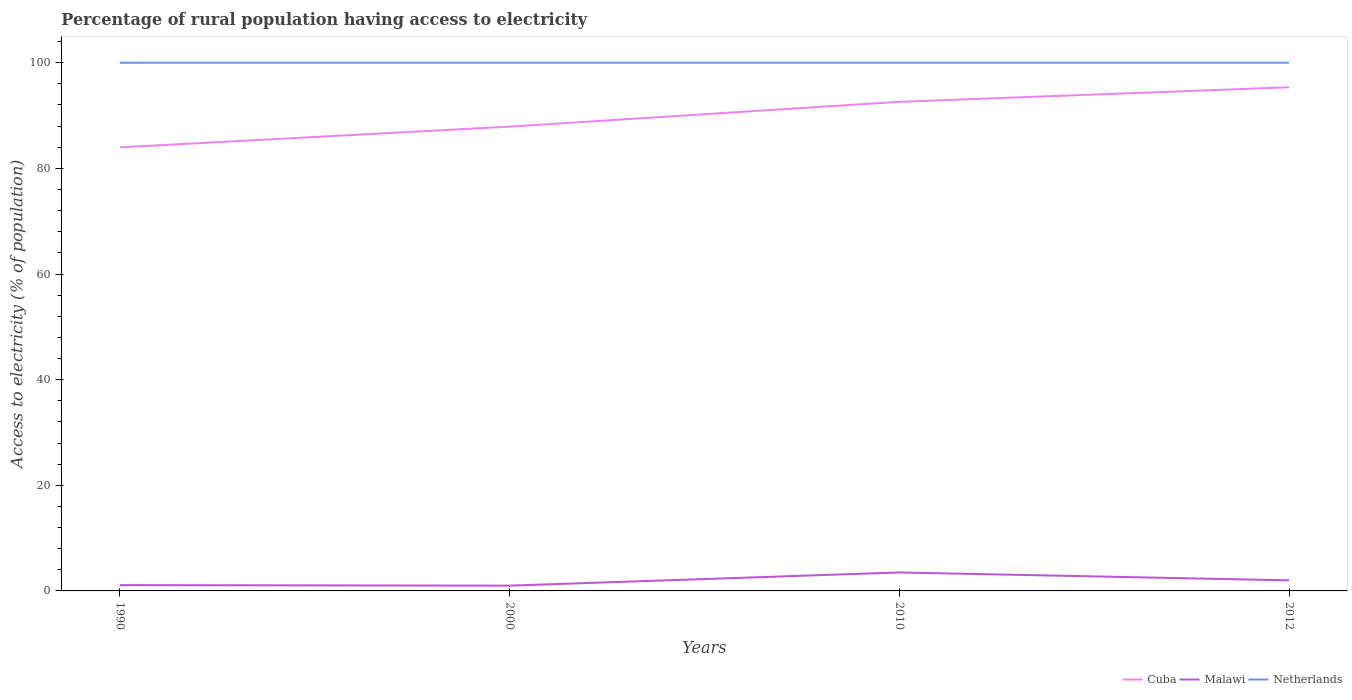Is the number of lines equal to the number of legend labels?
Offer a terse response. Yes. Across all years, what is the maximum percentage of rural population having access to electricity in Netherlands?
Your response must be concise. 100. Is the percentage of rural population having access to electricity in Malawi strictly greater than the percentage of rural population having access to electricity in Netherlands over the years?
Offer a terse response. Yes. Are the values on the major ticks of Y-axis written in scientific E-notation?
Make the answer very short. No. Does the graph contain any zero values?
Give a very brief answer. No. Does the graph contain grids?
Make the answer very short. No. How are the legend labels stacked?
Your answer should be compact. Horizontal. What is the title of the graph?
Give a very brief answer. Percentage of rural population having access to electricity. Does "Marshall Islands" appear as one of the legend labels in the graph?
Offer a very short reply. No. What is the label or title of the Y-axis?
Provide a succinct answer. Access to electricity (% of population). What is the Access to electricity (% of population) of Cuba in 1990?
Ensure brevity in your answer.  83.98. What is the Access to electricity (% of population) in Malawi in 1990?
Give a very brief answer. 1.1. What is the Access to electricity (% of population) in Netherlands in 1990?
Keep it short and to the point. 100. What is the Access to electricity (% of population) of Cuba in 2000?
Provide a short and direct response. 87.9. What is the Access to electricity (% of population) of Netherlands in 2000?
Give a very brief answer. 100. What is the Access to electricity (% of population) in Cuba in 2010?
Give a very brief answer. 92.6. What is the Access to electricity (% of population) in Malawi in 2010?
Keep it short and to the point. 3.5. What is the Access to electricity (% of population) in Cuba in 2012?
Offer a very short reply. 95.35. What is the Access to electricity (% of population) in Malawi in 2012?
Ensure brevity in your answer.  2. Across all years, what is the maximum Access to electricity (% of population) of Cuba?
Your response must be concise. 95.35. Across all years, what is the minimum Access to electricity (% of population) in Cuba?
Provide a succinct answer. 83.98. Across all years, what is the minimum Access to electricity (% of population) of Malawi?
Offer a terse response. 1. Across all years, what is the minimum Access to electricity (% of population) of Netherlands?
Your response must be concise. 100. What is the total Access to electricity (% of population) of Cuba in the graph?
Provide a succinct answer. 359.83. What is the difference between the Access to electricity (% of population) of Cuba in 1990 and that in 2000?
Provide a succinct answer. -3.92. What is the difference between the Access to electricity (% of population) of Netherlands in 1990 and that in 2000?
Your response must be concise. 0. What is the difference between the Access to electricity (% of population) in Cuba in 1990 and that in 2010?
Your answer should be very brief. -8.62. What is the difference between the Access to electricity (% of population) in Cuba in 1990 and that in 2012?
Give a very brief answer. -11.38. What is the difference between the Access to electricity (% of population) in Malawi in 1990 and that in 2012?
Your response must be concise. -0.9. What is the difference between the Access to electricity (% of population) in Netherlands in 1990 and that in 2012?
Keep it short and to the point. 0. What is the difference between the Access to electricity (% of population) of Netherlands in 2000 and that in 2010?
Make the answer very short. 0. What is the difference between the Access to electricity (% of population) in Cuba in 2000 and that in 2012?
Make the answer very short. -7.45. What is the difference between the Access to electricity (% of population) in Netherlands in 2000 and that in 2012?
Offer a terse response. 0. What is the difference between the Access to electricity (% of population) of Cuba in 2010 and that in 2012?
Your answer should be very brief. -2.75. What is the difference between the Access to electricity (% of population) of Netherlands in 2010 and that in 2012?
Make the answer very short. 0. What is the difference between the Access to electricity (% of population) in Cuba in 1990 and the Access to electricity (% of population) in Malawi in 2000?
Offer a very short reply. 82.98. What is the difference between the Access to electricity (% of population) in Cuba in 1990 and the Access to electricity (% of population) in Netherlands in 2000?
Your response must be concise. -16.02. What is the difference between the Access to electricity (% of population) in Malawi in 1990 and the Access to electricity (% of population) in Netherlands in 2000?
Offer a terse response. -98.9. What is the difference between the Access to electricity (% of population) of Cuba in 1990 and the Access to electricity (% of population) of Malawi in 2010?
Offer a very short reply. 80.48. What is the difference between the Access to electricity (% of population) of Cuba in 1990 and the Access to electricity (% of population) of Netherlands in 2010?
Your answer should be very brief. -16.02. What is the difference between the Access to electricity (% of population) of Malawi in 1990 and the Access to electricity (% of population) of Netherlands in 2010?
Offer a very short reply. -98.9. What is the difference between the Access to electricity (% of population) of Cuba in 1990 and the Access to electricity (% of population) of Malawi in 2012?
Ensure brevity in your answer.  81.98. What is the difference between the Access to electricity (% of population) of Cuba in 1990 and the Access to electricity (% of population) of Netherlands in 2012?
Offer a terse response. -16.02. What is the difference between the Access to electricity (% of population) of Malawi in 1990 and the Access to electricity (% of population) of Netherlands in 2012?
Keep it short and to the point. -98.9. What is the difference between the Access to electricity (% of population) in Cuba in 2000 and the Access to electricity (% of population) in Malawi in 2010?
Provide a short and direct response. 84.4. What is the difference between the Access to electricity (% of population) in Malawi in 2000 and the Access to electricity (% of population) in Netherlands in 2010?
Provide a succinct answer. -99. What is the difference between the Access to electricity (% of population) in Cuba in 2000 and the Access to electricity (% of population) in Malawi in 2012?
Offer a terse response. 85.9. What is the difference between the Access to electricity (% of population) of Cuba in 2000 and the Access to electricity (% of population) of Netherlands in 2012?
Offer a very short reply. -12.1. What is the difference between the Access to electricity (% of population) of Malawi in 2000 and the Access to electricity (% of population) of Netherlands in 2012?
Your answer should be compact. -99. What is the difference between the Access to electricity (% of population) of Cuba in 2010 and the Access to electricity (% of population) of Malawi in 2012?
Your answer should be very brief. 90.6. What is the difference between the Access to electricity (% of population) in Malawi in 2010 and the Access to electricity (% of population) in Netherlands in 2012?
Provide a short and direct response. -96.5. What is the average Access to electricity (% of population) in Cuba per year?
Your answer should be compact. 89.96. What is the average Access to electricity (% of population) of Malawi per year?
Offer a terse response. 1.9. What is the average Access to electricity (% of population) of Netherlands per year?
Your response must be concise. 100. In the year 1990, what is the difference between the Access to electricity (% of population) in Cuba and Access to electricity (% of population) in Malawi?
Provide a short and direct response. 82.88. In the year 1990, what is the difference between the Access to electricity (% of population) of Cuba and Access to electricity (% of population) of Netherlands?
Your answer should be compact. -16.02. In the year 1990, what is the difference between the Access to electricity (% of population) of Malawi and Access to electricity (% of population) of Netherlands?
Provide a short and direct response. -98.9. In the year 2000, what is the difference between the Access to electricity (% of population) in Cuba and Access to electricity (% of population) in Malawi?
Provide a short and direct response. 86.9. In the year 2000, what is the difference between the Access to electricity (% of population) in Cuba and Access to electricity (% of population) in Netherlands?
Your response must be concise. -12.1. In the year 2000, what is the difference between the Access to electricity (% of population) in Malawi and Access to electricity (% of population) in Netherlands?
Keep it short and to the point. -99. In the year 2010, what is the difference between the Access to electricity (% of population) of Cuba and Access to electricity (% of population) of Malawi?
Offer a terse response. 89.1. In the year 2010, what is the difference between the Access to electricity (% of population) in Cuba and Access to electricity (% of population) in Netherlands?
Keep it short and to the point. -7.4. In the year 2010, what is the difference between the Access to electricity (% of population) of Malawi and Access to electricity (% of population) of Netherlands?
Ensure brevity in your answer.  -96.5. In the year 2012, what is the difference between the Access to electricity (% of population) of Cuba and Access to electricity (% of population) of Malawi?
Make the answer very short. 93.35. In the year 2012, what is the difference between the Access to electricity (% of population) in Cuba and Access to electricity (% of population) in Netherlands?
Provide a succinct answer. -4.65. In the year 2012, what is the difference between the Access to electricity (% of population) in Malawi and Access to electricity (% of population) in Netherlands?
Ensure brevity in your answer.  -98. What is the ratio of the Access to electricity (% of population) in Cuba in 1990 to that in 2000?
Your response must be concise. 0.96. What is the ratio of the Access to electricity (% of population) of Cuba in 1990 to that in 2010?
Make the answer very short. 0.91. What is the ratio of the Access to electricity (% of population) of Malawi in 1990 to that in 2010?
Your answer should be compact. 0.31. What is the ratio of the Access to electricity (% of population) of Cuba in 1990 to that in 2012?
Offer a very short reply. 0.88. What is the ratio of the Access to electricity (% of population) in Malawi in 1990 to that in 2012?
Provide a short and direct response. 0.55. What is the ratio of the Access to electricity (% of population) of Netherlands in 1990 to that in 2012?
Offer a terse response. 1. What is the ratio of the Access to electricity (% of population) of Cuba in 2000 to that in 2010?
Give a very brief answer. 0.95. What is the ratio of the Access to electricity (% of population) of Malawi in 2000 to that in 2010?
Make the answer very short. 0.29. What is the ratio of the Access to electricity (% of population) of Cuba in 2000 to that in 2012?
Your response must be concise. 0.92. What is the ratio of the Access to electricity (% of population) in Cuba in 2010 to that in 2012?
Give a very brief answer. 0.97. What is the ratio of the Access to electricity (% of population) in Netherlands in 2010 to that in 2012?
Ensure brevity in your answer.  1. What is the difference between the highest and the second highest Access to electricity (% of population) in Cuba?
Your answer should be compact. 2.75. What is the difference between the highest and the second highest Access to electricity (% of population) in Netherlands?
Make the answer very short. 0. What is the difference between the highest and the lowest Access to electricity (% of population) of Cuba?
Give a very brief answer. 11.38. 